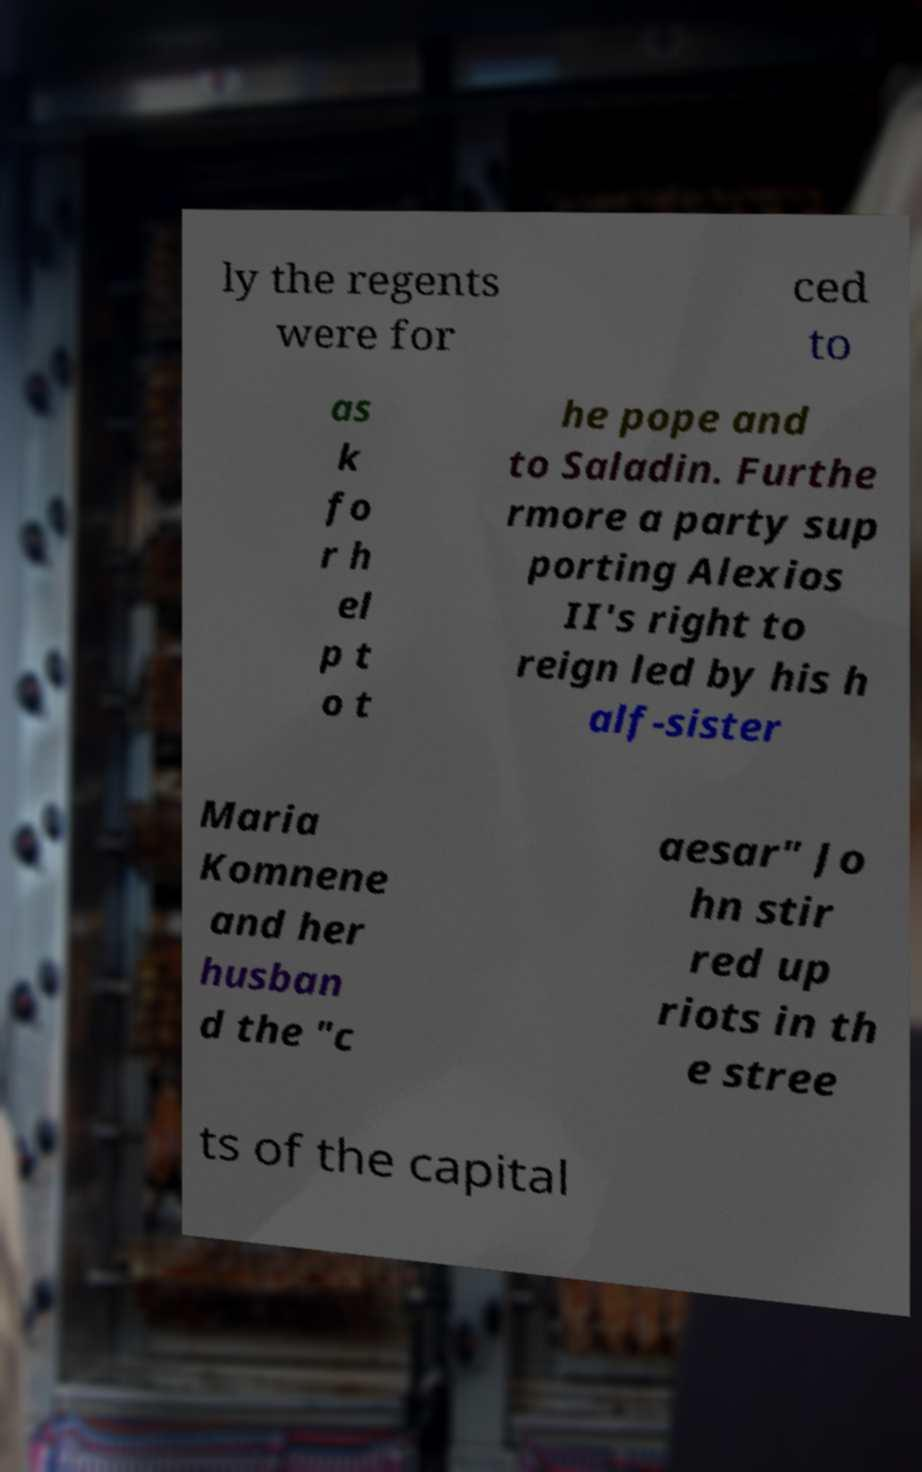What messages or text are displayed in this image? I need them in a readable, typed format. ly the regents were for ced to as k fo r h el p t o t he pope and to Saladin. Furthe rmore a party sup porting Alexios II's right to reign led by his h alf-sister Maria Komnene and her husban d the "c aesar" Jo hn stir red up riots in th e stree ts of the capital 